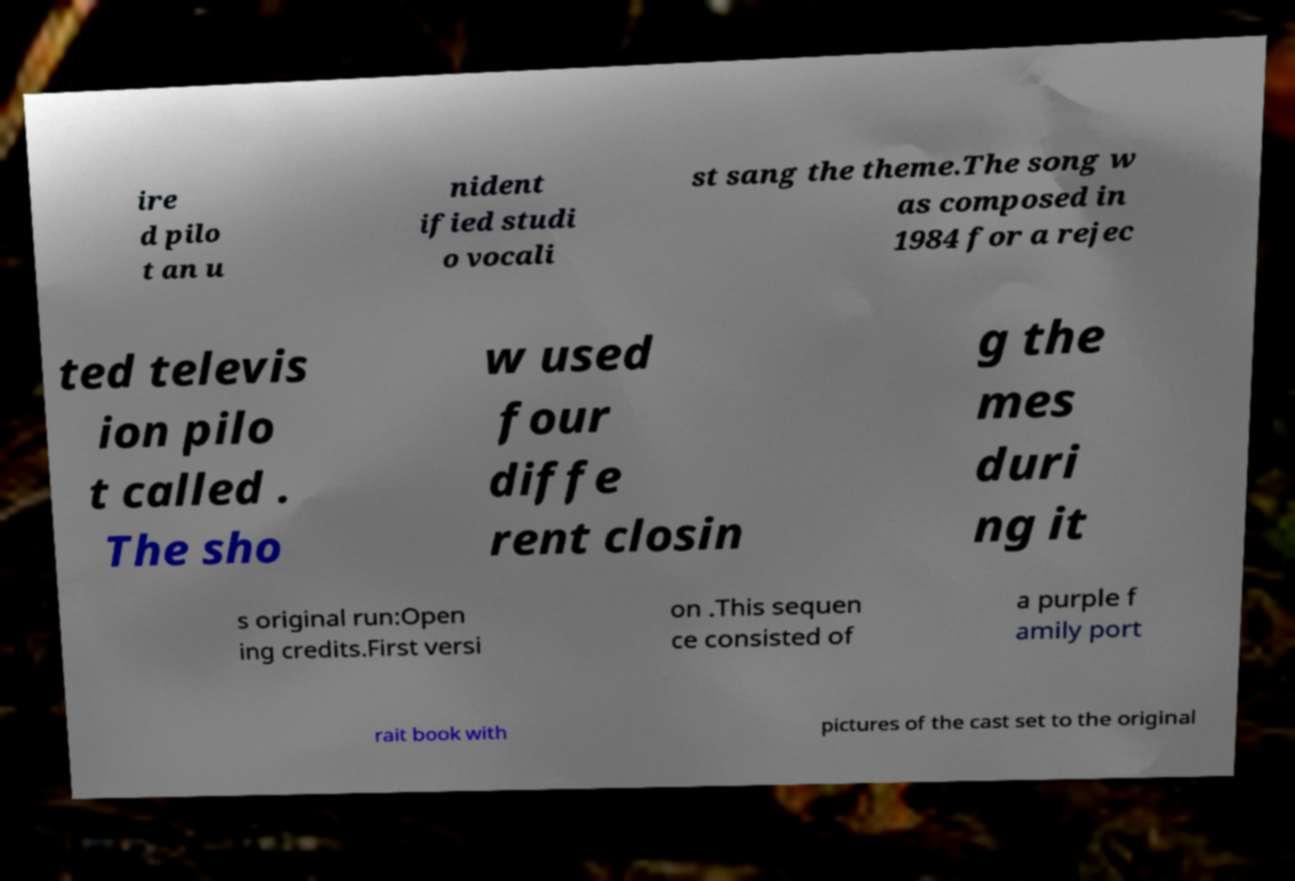Please identify and transcribe the text found in this image. ire d pilo t an u nident ified studi o vocali st sang the theme.The song w as composed in 1984 for a rejec ted televis ion pilo t called . The sho w used four diffe rent closin g the mes duri ng it s original run:Open ing credits.First versi on .This sequen ce consisted of a purple f amily port rait book with pictures of the cast set to the original 